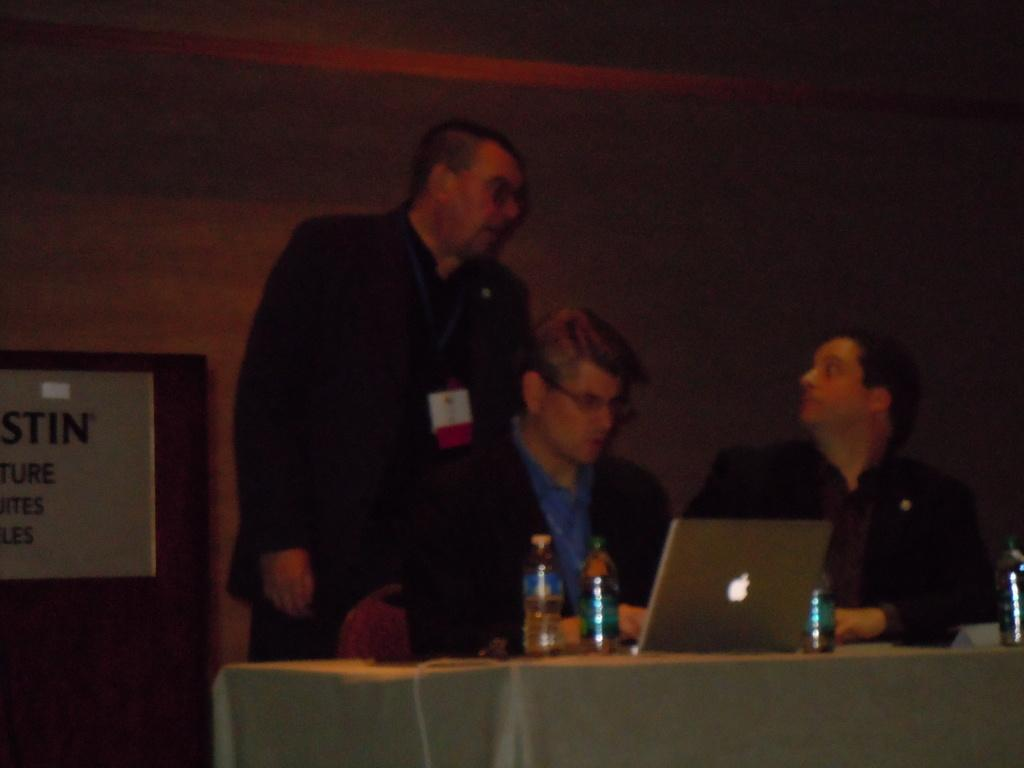How many people are sitting in the image? There are two people sitting on chairs in the image. What is the position of the third person in the image? There is a person standing on a surface in the image. What objects can be seen on the table in the image? Bottles and electronic devices are visible on a table in the image. What type of calendar is hanging on the wall in the image? There is no calendar present in the image. How many pies are being served by the woman in the image? There is no woman or pies present in the image. 